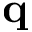Convert formula to latex. <formula><loc_0><loc_0><loc_500><loc_500>q</formula> 